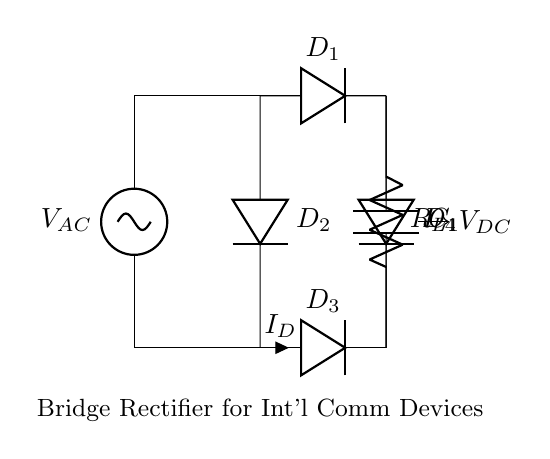What is the type of this circuit? This circuit is a bridge rectifier, which is specifically designed to convert alternating current (AC) into direct current (DC). The structure includes four diodes arranged in a bridge configuration, enabling the rectification process.
Answer: bridge rectifier How many diodes are in this circuit? The circuit consists of four diodes labeled as D1, D2, D3, and D4. Each diode is responsible for allowing current to pass in one direction during the rectification process.
Answer: four diodes What does the capacitor do in this circuit? The capacitor, labeled as C1, serves the purpose of smoothing the rectified output voltage. It charges during the peaks of the rectified voltage and releases energy during the drops, thus reducing the ripple in the DC output.
Answer: smoothing What is the load connected to the circuit? The load in this circuit is represented by the resistor labeled R_L. This resistor represents the device or component that utilizes the DC power supplied by the bridge rectifier for its operation.
Answer: resistor What is the output voltage type of this circuit? The output voltage of this circuit is direct current (DC), as indicated by the label V_DC. The bridge rectifier converts the input AC voltage into a usable DC voltage for powering devices.
Answer: direct current Which diodes conduct during the positive half-cycle of AC input? During the positive half-cycle of the AC input, diodes D1 and D2 conduct, allowing current to flow through them to the load, while D3 and D4 are reverse-biased and do not conduct.
Answer: D1 and D2 How does the bridge rectifier improve efficiency compared to a single diode rectifier? The bridge rectifier improves efficiency by allowing both halves of the AC waveform to be used, effectively doubling the output voltage and reducing losses that occur in a single diode rectifier whose efficiency is limited to half of the input waveform.
Answer: efficiency increased 